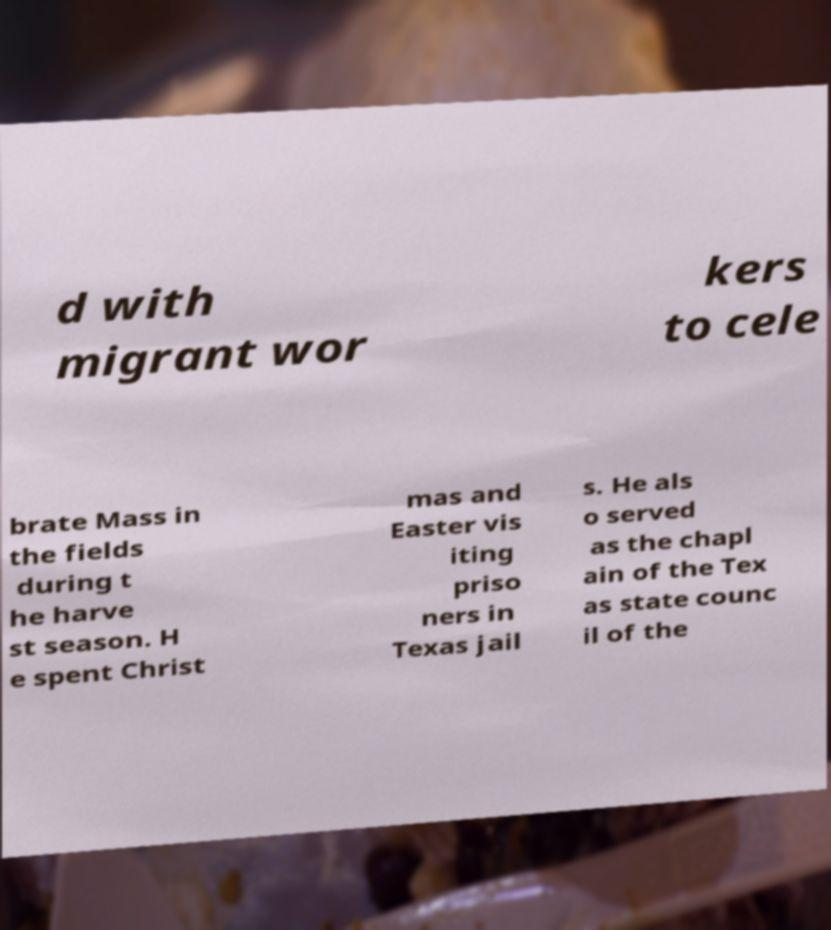I need the written content from this picture converted into text. Can you do that? d with migrant wor kers to cele brate Mass in the fields during t he harve st season. H e spent Christ mas and Easter vis iting priso ners in Texas jail s. He als o served as the chapl ain of the Tex as state counc il of the 